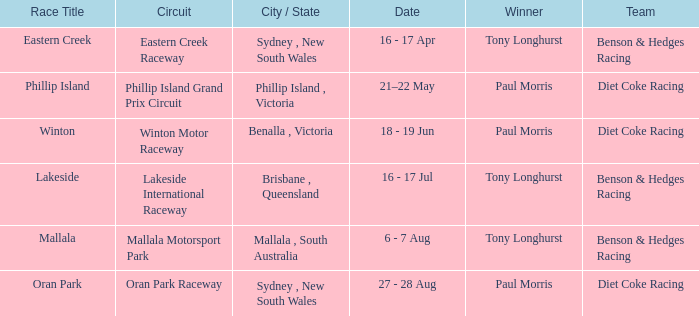When was the Mallala race held? 6 - 7 Aug. 